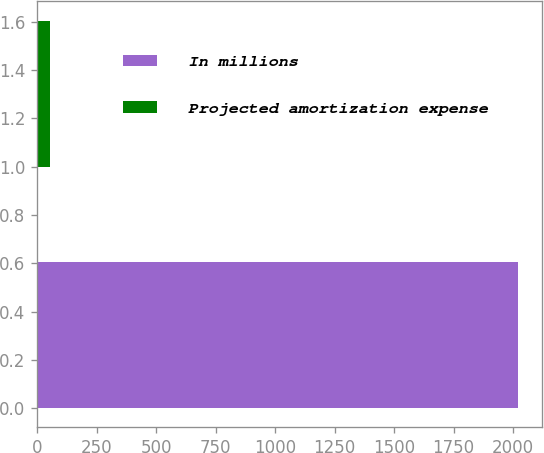<chart> <loc_0><loc_0><loc_500><loc_500><bar_chart><fcel>In millions<fcel>Projected amortization expense<nl><fcel>2019<fcel>56<nl></chart> 